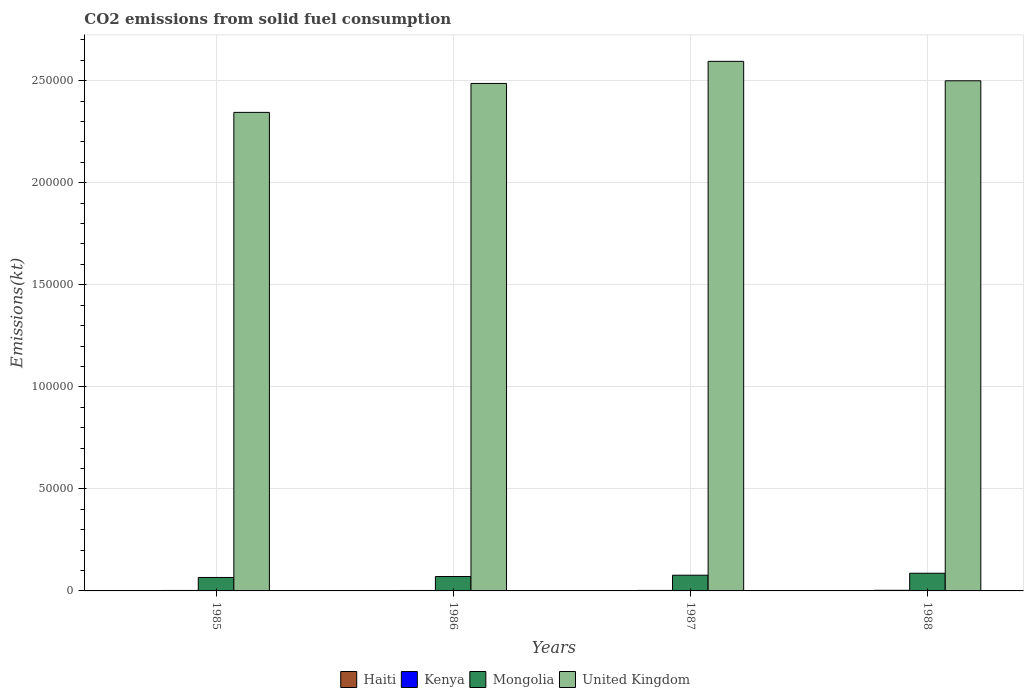How many groups of bars are there?
Keep it short and to the point. 4. How many bars are there on the 4th tick from the left?
Your response must be concise. 4. What is the label of the 1st group of bars from the left?
Offer a very short reply. 1985. In how many cases, is the number of bars for a given year not equal to the number of legend labels?
Keep it short and to the point. 0. What is the amount of CO2 emitted in United Kingdom in 1987?
Your answer should be compact. 2.59e+05. Across all years, what is the maximum amount of CO2 emitted in Kenya?
Provide a short and direct response. 300.69. Across all years, what is the minimum amount of CO2 emitted in Haiti?
Your answer should be very brief. 47.67. What is the total amount of CO2 emitted in Haiti in the graph?
Ensure brevity in your answer.  337.36. What is the difference between the amount of CO2 emitted in Haiti in 1986 and that in 1988?
Your answer should be compact. -33. What is the difference between the amount of CO2 emitted in United Kingdom in 1988 and the amount of CO2 emitted in Kenya in 1986?
Your response must be concise. 2.50e+05. What is the average amount of CO2 emitted in Kenya per year?
Your response must be concise. 251.19. In the year 1985, what is the difference between the amount of CO2 emitted in Kenya and amount of CO2 emitted in Mongolia?
Ensure brevity in your answer.  -6362.24. In how many years, is the amount of CO2 emitted in Haiti greater than 260000 kt?
Provide a succinct answer. 0. What is the ratio of the amount of CO2 emitted in Kenya in 1985 to that in 1988?
Ensure brevity in your answer.  0.77. Is the amount of CO2 emitted in Kenya in 1987 less than that in 1988?
Provide a succinct answer. Yes. Is the difference between the amount of CO2 emitted in Kenya in 1986 and 1987 greater than the difference between the amount of CO2 emitted in Mongolia in 1986 and 1987?
Give a very brief answer. Yes. What is the difference between the highest and the second highest amount of CO2 emitted in Mongolia?
Ensure brevity in your answer.  964.42. What is the difference between the highest and the lowest amount of CO2 emitted in United Kingdom?
Provide a short and direct response. 2.50e+04. In how many years, is the amount of CO2 emitted in Kenya greater than the average amount of CO2 emitted in Kenya taken over all years?
Provide a succinct answer. 1. Is the sum of the amount of CO2 emitted in Mongolia in 1985 and 1988 greater than the maximum amount of CO2 emitted in Kenya across all years?
Give a very brief answer. Yes. What does the 1st bar from the right in 1987 represents?
Offer a very short reply. United Kingdom. Is it the case that in every year, the sum of the amount of CO2 emitted in United Kingdom and amount of CO2 emitted in Kenya is greater than the amount of CO2 emitted in Mongolia?
Your answer should be compact. Yes. Are all the bars in the graph horizontal?
Your response must be concise. No. How are the legend labels stacked?
Offer a terse response. Horizontal. What is the title of the graph?
Provide a succinct answer. CO2 emissions from solid fuel consumption. What is the label or title of the X-axis?
Your answer should be compact. Years. What is the label or title of the Y-axis?
Your answer should be compact. Emissions(kt). What is the Emissions(kt) of Haiti in 1985?
Your answer should be very brief. 161.35. What is the Emissions(kt) in Kenya in 1985?
Your answer should be compact. 231.02. What is the Emissions(kt) of Mongolia in 1985?
Your answer should be compact. 6593.27. What is the Emissions(kt) of United Kingdom in 1985?
Provide a short and direct response. 2.34e+05. What is the Emissions(kt) in Haiti in 1986?
Provide a succinct answer. 47.67. What is the Emissions(kt) of Kenya in 1986?
Offer a very short reply. 227.35. What is the Emissions(kt) in Mongolia in 1986?
Your response must be concise. 7055.31. What is the Emissions(kt) in United Kingdom in 1986?
Give a very brief answer. 2.49e+05. What is the Emissions(kt) of Haiti in 1987?
Provide a short and direct response. 47.67. What is the Emissions(kt) in Kenya in 1987?
Your answer should be very brief. 245.69. What is the Emissions(kt) of Mongolia in 1987?
Keep it short and to the point. 7697.03. What is the Emissions(kt) of United Kingdom in 1987?
Provide a short and direct response. 2.59e+05. What is the Emissions(kt) of Haiti in 1988?
Provide a short and direct response. 80.67. What is the Emissions(kt) of Kenya in 1988?
Offer a very short reply. 300.69. What is the Emissions(kt) of Mongolia in 1988?
Your answer should be very brief. 8661.45. What is the Emissions(kt) of United Kingdom in 1988?
Make the answer very short. 2.50e+05. Across all years, what is the maximum Emissions(kt) in Haiti?
Give a very brief answer. 161.35. Across all years, what is the maximum Emissions(kt) in Kenya?
Your answer should be very brief. 300.69. Across all years, what is the maximum Emissions(kt) in Mongolia?
Your answer should be very brief. 8661.45. Across all years, what is the maximum Emissions(kt) in United Kingdom?
Offer a terse response. 2.59e+05. Across all years, what is the minimum Emissions(kt) in Haiti?
Provide a short and direct response. 47.67. Across all years, what is the minimum Emissions(kt) of Kenya?
Your answer should be compact. 227.35. Across all years, what is the minimum Emissions(kt) in Mongolia?
Make the answer very short. 6593.27. Across all years, what is the minimum Emissions(kt) in United Kingdom?
Your answer should be compact. 2.34e+05. What is the total Emissions(kt) in Haiti in the graph?
Provide a short and direct response. 337.36. What is the total Emissions(kt) in Kenya in the graph?
Provide a succinct answer. 1004.76. What is the total Emissions(kt) of Mongolia in the graph?
Provide a short and direct response. 3.00e+04. What is the total Emissions(kt) in United Kingdom in the graph?
Your answer should be very brief. 9.93e+05. What is the difference between the Emissions(kt) in Haiti in 1985 and that in 1986?
Offer a terse response. 113.68. What is the difference between the Emissions(kt) in Kenya in 1985 and that in 1986?
Your answer should be very brief. 3.67. What is the difference between the Emissions(kt) of Mongolia in 1985 and that in 1986?
Make the answer very short. -462.04. What is the difference between the Emissions(kt) in United Kingdom in 1985 and that in 1986?
Ensure brevity in your answer.  -1.42e+04. What is the difference between the Emissions(kt) in Haiti in 1985 and that in 1987?
Keep it short and to the point. 113.68. What is the difference between the Emissions(kt) of Kenya in 1985 and that in 1987?
Provide a succinct answer. -14.67. What is the difference between the Emissions(kt) in Mongolia in 1985 and that in 1987?
Your answer should be very brief. -1103.77. What is the difference between the Emissions(kt) in United Kingdom in 1985 and that in 1987?
Offer a terse response. -2.50e+04. What is the difference between the Emissions(kt) of Haiti in 1985 and that in 1988?
Ensure brevity in your answer.  80.67. What is the difference between the Emissions(kt) in Kenya in 1985 and that in 1988?
Offer a terse response. -69.67. What is the difference between the Emissions(kt) of Mongolia in 1985 and that in 1988?
Ensure brevity in your answer.  -2068.19. What is the difference between the Emissions(kt) in United Kingdom in 1985 and that in 1988?
Provide a succinct answer. -1.55e+04. What is the difference between the Emissions(kt) of Kenya in 1986 and that in 1987?
Provide a succinct answer. -18.34. What is the difference between the Emissions(kt) of Mongolia in 1986 and that in 1987?
Your answer should be compact. -641.73. What is the difference between the Emissions(kt) of United Kingdom in 1986 and that in 1987?
Provide a succinct answer. -1.08e+04. What is the difference between the Emissions(kt) in Haiti in 1986 and that in 1988?
Your response must be concise. -33. What is the difference between the Emissions(kt) of Kenya in 1986 and that in 1988?
Provide a succinct answer. -73.34. What is the difference between the Emissions(kt) of Mongolia in 1986 and that in 1988?
Your answer should be compact. -1606.15. What is the difference between the Emissions(kt) of United Kingdom in 1986 and that in 1988?
Your response must be concise. -1294.45. What is the difference between the Emissions(kt) in Haiti in 1987 and that in 1988?
Offer a very short reply. -33. What is the difference between the Emissions(kt) of Kenya in 1987 and that in 1988?
Your answer should be very brief. -55.01. What is the difference between the Emissions(kt) in Mongolia in 1987 and that in 1988?
Make the answer very short. -964.42. What is the difference between the Emissions(kt) in United Kingdom in 1987 and that in 1988?
Your response must be concise. 9523.2. What is the difference between the Emissions(kt) of Haiti in 1985 and the Emissions(kt) of Kenya in 1986?
Make the answer very short. -66.01. What is the difference between the Emissions(kt) in Haiti in 1985 and the Emissions(kt) in Mongolia in 1986?
Provide a short and direct response. -6893.96. What is the difference between the Emissions(kt) of Haiti in 1985 and the Emissions(kt) of United Kingdom in 1986?
Offer a very short reply. -2.49e+05. What is the difference between the Emissions(kt) in Kenya in 1985 and the Emissions(kt) in Mongolia in 1986?
Make the answer very short. -6824.29. What is the difference between the Emissions(kt) in Kenya in 1985 and the Emissions(kt) in United Kingdom in 1986?
Your response must be concise. -2.48e+05. What is the difference between the Emissions(kt) in Mongolia in 1985 and the Emissions(kt) in United Kingdom in 1986?
Your answer should be compact. -2.42e+05. What is the difference between the Emissions(kt) of Haiti in 1985 and the Emissions(kt) of Kenya in 1987?
Your answer should be compact. -84.34. What is the difference between the Emissions(kt) in Haiti in 1985 and the Emissions(kt) in Mongolia in 1987?
Give a very brief answer. -7535.69. What is the difference between the Emissions(kt) of Haiti in 1985 and the Emissions(kt) of United Kingdom in 1987?
Your response must be concise. -2.59e+05. What is the difference between the Emissions(kt) in Kenya in 1985 and the Emissions(kt) in Mongolia in 1987?
Make the answer very short. -7466.01. What is the difference between the Emissions(kt) of Kenya in 1985 and the Emissions(kt) of United Kingdom in 1987?
Your answer should be compact. -2.59e+05. What is the difference between the Emissions(kt) of Mongolia in 1985 and the Emissions(kt) of United Kingdom in 1987?
Ensure brevity in your answer.  -2.53e+05. What is the difference between the Emissions(kt) in Haiti in 1985 and the Emissions(kt) in Kenya in 1988?
Ensure brevity in your answer.  -139.35. What is the difference between the Emissions(kt) of Haiti in 1985 and the Emissions(kt) of Mongolia in 1988?
Offer a very short reply. -8500.11. What is the difference between the Emissions(kt) of Haiti in 1985 and the Emissions(kt) of United Kingdom in 1988?
Keep it short and to the point. -2.50e+05. What is the difference between the Emissions(kt) in Kenya in 1985 and the Emissions(kt) in Mongolia in 1988?
Ensure brevity in your answer.  -8430.43. What is the difference between the Emissions(kt) in Kenya in 1985 and the Emissions(kt) in United Kingdom in 1988?
Make the answer very short. -2.50e+05. What is the difference between the Emissions(kt) in Mongolia in 1985 and the Emissions(kt) in United Kingdom in 1988?
Your response must be concise. -2.43e+05. What is the difference between the Emissions(kt) in Haiti in 1986 and the Emissions(kt) in Kenya in 1987?
Give a very brief answer. -198.02. What is the difference between the Emissions(kt) of Haiti in 1986 and the Emissions(kt) of Mongolia in 1987?
Your answer should be compact. -7649.36. What is the difference between the Emissions(kt) of Haiti in 1986 and the Emissions(kt) of United Kingdom in 1987?
Provide a succinct answer. -2.59e+05. What is the difference between the Emissions(kt) in Kenya in 1986 and the Emissions(kt) in Mongolia in 1987?
Offer a very short reply. -7469.68. What is the difference between the Emissions(kt) of Kenya in 1986 and the Emissions(kt) of United Kingdom in 1987?
Provide a short and direct response. -2.59e+05. What is the difference between the Emissions(kt) of Mongolia in 1986 and the Emissions(kt) of United Kingdom in 1987?
Keep it short and to the point. -2.52e+05. What is the difference between the Emissions(kt) of Haiti in 1986 and the Emissions(kt) of Kenya in 1988?
Keep it short and to the point. -253.02. What is the difference between the Emissions(kt) of Haiti in 1986 and the Emissions(kt) of Mongolia in 1988?
Your answer should be compact. -8613.78. What is the difference between the Emissions(kt) of Haiti in 1986 and the Emissions(kt) of United Kingdom in 1988?
Offer a terse response. -2.50e+05. What is the difference between the Emissions(kt) of Kenya in 1986 and the Emissions(kt) of Mongolia in 1988?
Provide a short and direct response. -8434.1. What is the difference between the Emissions(kt) of Kenya in 1986 and the Emissions(kt) of United Kingdom in 1988?
Your answer should be compact. -2.50e+05. What is the difference between the Emissions(kt) of Mongolia in 1986 and the Emissions(kt) of United Kingdom in 1988?
Your answer should be compact. -2.43e+05. What is the difference between the Emissions(kt) in Haiti in 1987 and the Emissions(kt) in Kenya in 1988?
Offer a very short reply. -253.02. What is the difference between the Emissions(kt) in Haiti in 1987 and the Emissions(kt) in Mongolia in 1988?
Your answer should be very brief. -8613.78. What is the difference between the Emissions(kt) of Haiti in 1987 and the Emissions(kt) of United Kingdom in 1988?
Offer a terse response. -2.50e+05. What is the difference between the Emissions(kt) of Kenya in 1987 and the Emissions(kt) of Mongolia in 1988?
Ensure brevity in your answer.  -8415.76. What is the difference between the Emissions(kt) of Kenya in 1987 and the Emissions(kt) of United Kingdom in 1988?
Your answer should be compact. -2.50e+05. What is the difference between the Emissions(kt) of Mongolia in 1987 and the Emissions(kt) of United Kingdom in 1988?
Your answer should be compact. -2.42e+05. What is the average Emissions(kt) in Haiti per year?
Provide a succinct answer. 84.34. What is the average Emissions(kt) of Kenya per year?
Your answer should be very brief. 251.19. What is the average Emissions(kt) in Mongolia per year?
Keep it short and to the point. 7501.77. What is the average Emissions(kt) in United Kingdom per year?
Keep it short and to the point. 2.48e+05. In the year 1985, what is the difference between the Emissions(kt) in Haiti and Emissions(kt) in Kenya?
Your answer should be very brief. -69.67. In the year 1985, what is the difference between the Emissions(kt) in Haiti and Emissions(kt) in Mongolia?
Your response must be concise. -6431.92. In the year 1985, what is the difference between the Emissions(kt) of Haiti and Emissions(kt) of United Kingdom?
Your answer should be compact. -2.34e+05. In the year 1985, what is the difference between the Emissions(kt) of Kenya and Emissions(kt) of Mongolia?
Your answer should be very brief. -6362.24. In the year 1985, what is the difference between the Emissions(kt) in Kenya and Emissions(kt) in United Kingdom?
Your answer should be very brief. -2.34e+05. In the year 1985, what is the difference between the Emissions(kt) in Mongolia and Emissions(kt) in United Kingdom?
Make the answer very short. -2.28e+05. In the year 1986, what is the difference between the Emissions(kt) of Haiti and Emissions(kt) of Kenya?
Offer a terse response. -179.68. In the year 1986, what is the difference between the Emissions(kt) in Haiti and Emissions(kt) in Mongolia?
Ensure brevity in your answer.  -7007.64. In the year 1986, what is the difference between the Emissions(kt) in Haiti and Emissions(kt) in United Kingdom?
Keep it short and to the point. -2.49e+05. In the year 1986, what is the difference between the Emissions(kt) in Kenya and Emissions(kt) in Mongolia?
Offer a terse response. -6827.95. In the year 1986, what is the difference between the Emissions(kt) in Kenya and Emissions(kt) in United Kingdom?
Your answer should be very brief. -2.48e+05. In the year 1986, what is the difference between the Emissions(kt) of Mongolia and Emissions(kt) of United Kingdom?
Ensure brevity in your answer.  -2.42e+05. In the year 1987, what is the difference between the Emissions(kt) of Haiti and Emissions(kt) of Kenya?
Give a very brief answer. -198.02. In the year 1987, what is the difference between the Emissions(kt) in Haiti and Emissions(kt) in Mongolia?
Your response must be concise. -7649.36. In the year 1987, what is the difference between the Emissions(kt) of Haiti and Emissions(kt) of United Kingdom?
Offer a very short reply. -2.59e+05. In the year 1987, what is the difference between the Emissions(kt) of Kenya and Emissions(kt) of Mongolia?
Offer a very short reply. -7451.34. In the year 1987, what is the difference between the Emissions(kt) of Kenya and Emissions(kt) of United Kingdom?
Make the answer very short. -2.59e+05. In the year 1987, what is the difference between the Emissions(kt) in Mongolia and Emissions(kt) in United Kingdom?
Offer a very short reply. -2.52e+05. In the year 1988, what is the difference between the Emissions(kt) in Haiti and Emissions(kt) in Kenya?
Your answer should be compact. -220.02. In the year 1988, what is the difference between the Emissions(kt) in Haiti and Emissions(kt) in Mongolia?
Ensure brevity in your answer.  -8580.78. In the year 1988, what is the difference between the Emissions(kt) of Haiti and Emissions(kt) of United Kingdom?
Your answer should be compact. -2.50e+05. In the year 1988, what is the difference between the Emissions(kt) in Kenya and Emissions(kt) in Mongolia?
Keep it short and to the point. -8360.76. In the year 1988, what is the difference between the Emissions(kt) in Kenya and Emissions(kt) in United Kingdom?
Your answer should be compact. -2.50e+05. In the year 1988, what is the difference between the Emissions(kt) in Mongolia and Emissions(kt) in United Kingdom?
Give a very brief answer. -2.41e+05. What is the ratio of the Emissions(kt) in Haiti in 1985 to that in 1986?
Offer a terse response. 3.38. What is the ratio of the Emissions(kt) in Kenya in 1985 to that in 1986?
Your answer should be very brief. 1.02. What is the ratio of the Emissions(kt) in Mongolia in 1985 to that in 1986?
Keep it short and to the point. 0.93. What is the ratio of the Emissions(kt) in United Kingdom in 1985 to that in 1986?
Ensure brevity in your answer.  0.94. What is the ratio of the Emissions(kt) in Haiti in 1985 to that in 1987?
Provide a succinct answer. 3.38. What is the ratio of the Emissions(kt) of Kenya in 1985 to that in 1987?
Provide a short and direct response. 0.94. What is the ratio of the Emissions(kt) in Mongolia in 1985 to that in 1987?
Ensure brevity in your answer.  0.86. What is the ratio of the Emissions(kt) in United Kingdom in 1985 to that in 1987?
Give a very brief answer. 0.9. What is the ratio of the Emissions(kt) in Haiti in 1985 to that in 1988?
Ensure brevity in your answer.  2. What is the ratio of the Emissions(kt) in Kenya in 1985 to that in 1988?
Your response must be concise. 0.77. What is the ratio of the Emissions(kt) of Mongolia in 1985 to that in 1988?
Your answer should be compact. 0.76. What is the ratio of the Emissions(kt) of United Kingdom in 1985 to that in 1988?
Keep it short and to the point. 0.94. What is the ratio of the Emissions(kt) in Haiti in 1986 to that in 1987?
Your answer should be compact. 1. What is the ratio of the Emissions(kt) of Kenya in 1986 to that in 1987?
Your answer should be compact. 0.93. What is the ratio of the Emissions(kt) of Mongolia in 1986 to that in 1987?
Your response must be concise. 0.92. What is the ratio of the Emissions(kt) of Haiti in 1986 to that in 1988?
Provide a succinct answer. 0.59. What is the ratio of the Emissions(kt) in Kenya in 1986 to that in 1988?
Provide a short and direct response. 0.76. What is the ratio of the Emissions(kt) in Mongolia in 1986 to that in 1988?
Ensure brevity in your answer.  0.81. What is the ratio of the Emissions(kt) of United Kingdom in 1986 to that in 1988?
Provide a succinct answer. 0.99. What is the ratio of the Emissions(kt) in Haiti in 1987 to that in 1988?
Provide a short and direct response. 0.59. What is the ratio of the Emissions(kt) in Kenya in 1987 to that in 1988?
Your answer should be very brief. 0.82. What is the ratio of the Emissions(kt) of Mongolia in 1987 to that in 1988?
Provide a succinct answer. 0.89. What is the ratio of the Emissions(kt) of United Kingdom in 1987 to that in 1988?
Provide a short and direct response. 1.04. What is the difference between the highest and the second highest Emissions(kt) in Haiti?
Provide a short and direct response. 80.67. What is the difference between the highest and the second highest Emissions(kt) of Kenya?
Provide a succinct answer. 55.01. What is the difference between the highest and the second highest Emissions(kt) of Mongolia?
Provide a short and direct response. 964.42. What is the difference between the highest and the second highest Emissions(kt) in United Kingdom?
Give a very brief answer. 9523.2. What is the difference between the highest and the lowest Emissions(kt) of Haiti?
Keep it short and to the point. 113.68. What is the difference between the highest and the lowest Emissions(kt) of Kenya?
Your response must be concise. 73.34. What is the difference between the highest and the lowest Emissions(kt) in Mongolia?
Make the answer very short. 2068.19. What is the difference between the highest and the lowest Emissions(kt) in United Kingdom?
Your answer should be very brief. 2.50e+04. 